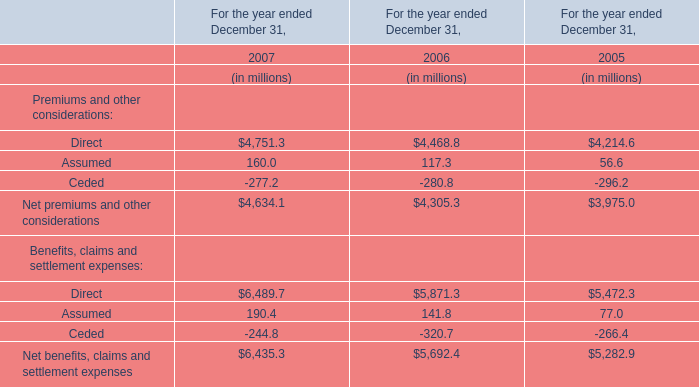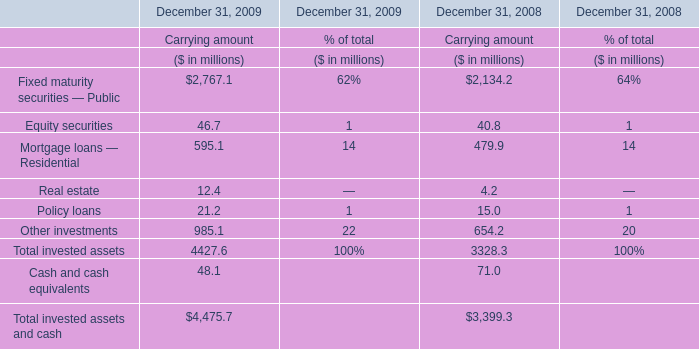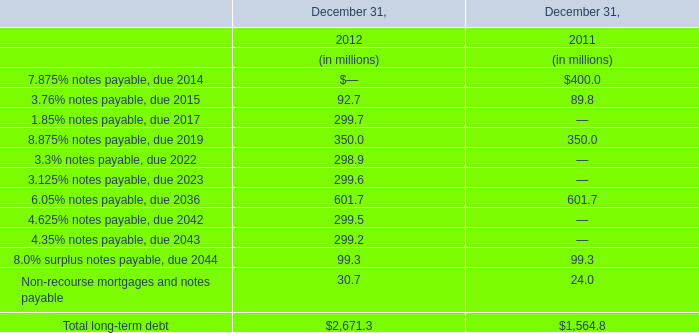The total amount of which section ranks first? (in million) 
Answer: 4475.7. 